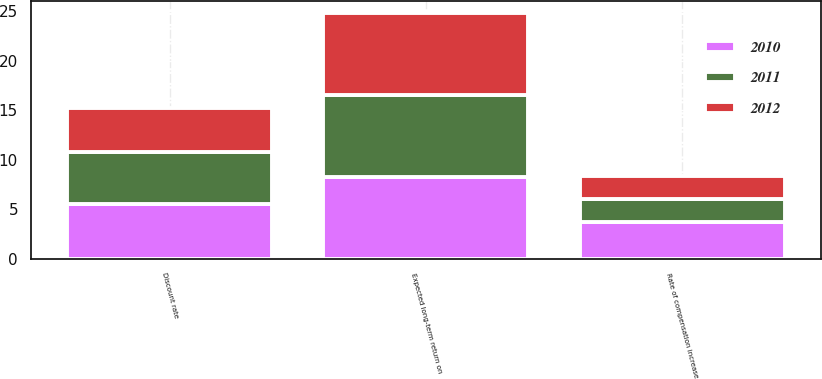<chart> <loc_0><loc_0><loc_500><loc_500><stacked_bar_chart><ecel><fcel>Discount rate<fcel>Expected long-term return on<fcel>Rate of compensation increase<nl><fcel>2012<fcel>4.4<fcel>8.2<fcel>2.3<nl><fcel>2011<fcel>5.2<fcel>8.3<fcel>2.4<nl><fcel>2010<fcel>5.6<fcel>8.3<fcel>3.7<nl></chart> 